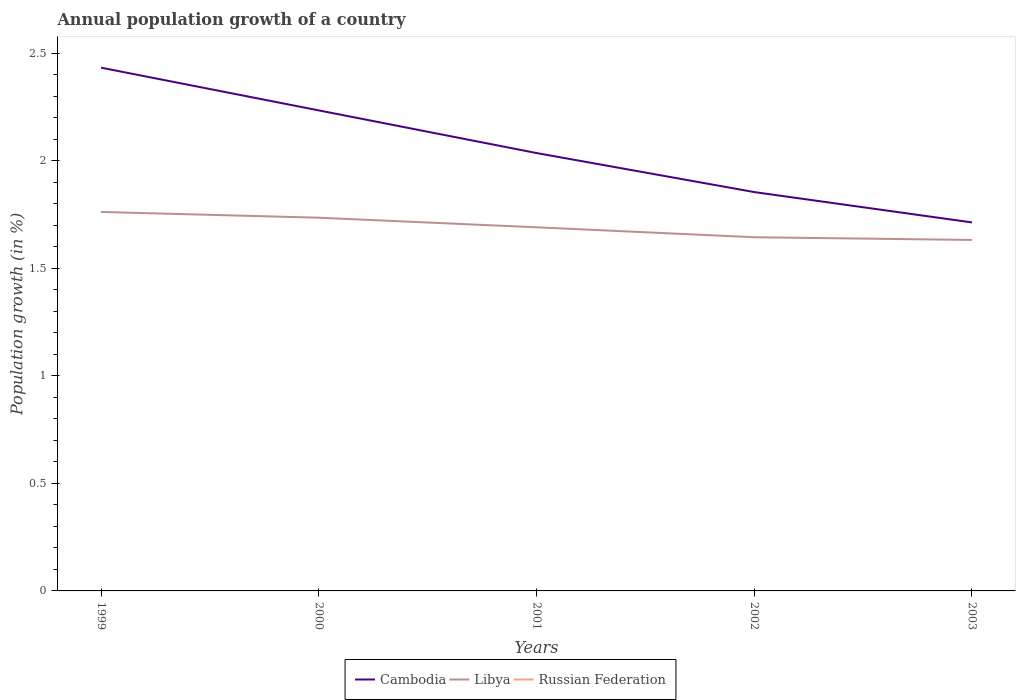Does the line corresponding to Libya intersect with the line corresponding to Cambodia?
Ensure brevity in your answer.  No. Across all years, what is the maximum annual population growth in Cambodia?
Make the answer very short. 1.71. What is the total annual population growth in Cambodia in the graph?
Ensure brevity in your answer.  0.2. What is the difference between the highest and the second highest annual population growth in Cambodia?
Your response must be concise. 0.72. What is the difference between the highest and the lowest annual population growth in Russian Federation?
Keep it short and to the point. 0. How many lines are there?
Offer a terse response. 2. How many years are there in the graph?
Give a very brief answer. 5. Does the graph contain any zero values?
Keep it short and to the point. Yes. Where does the legend appear in the graph?
Give a very brief answer. Bottom center. What is the title of the graph?
Keep it short and to the point. Annual population growth of a country. Does "San Marino" appear as one of the legend labels in the graph?
Make the answer very short. No. What is the label or title of the X-axis?
Your answer should be compact. Years. What is the label or title of the Y-axis?
Ensure brevity in your answer.  Population growth (in %). What is the Population growth (in %) in Cambodia in 1999?
Give a very brief answer. 2.43. What is the Population growth (in %) in Libya in 1999?
Offer a very short reply. 1.76. What is the Population growth (in %) in Russian Federation in 1999?
Offer a very short reply. 0. What is the Population growth (in %) of Cambodia in 2000?
Offer a very short reply. 2.23. What is the Population growth (in %) in Libya in 2000?
Your answer should be very brief. 1.74. What is the Population growth (in %) of Cambodia in 2001?
Your response must be concise. 2.04. What is the Population growth (in %) in Libya in 2001?
Provide a short and direct response. 1.69. What is the Population growth (in %) of Cambodia in 2002?
Provide a succinct answer. 1.86. What is the Population growth (in %) of Libya in 2002?
Provide a short and direct response. 1.65. What is the Population growth (in %) of Cambodia in 2003?
Keep it short and to the point. 1.71. What is the Population growth (in %) in Libya in 2003?
Your answer should be compact. 1.63. Across all years, what is the maximum Population growth (in %) of Cambodia?
Offer a very short reply. 2.43. Across all years, what is the maximum Population growth (in %) in Libya?
Your response must be concise. 1.76. Across all years, what is the minimum Population growth (in %) in Cambodia?
Your answer should be compact. 1.71. Across all years, what is the minimum Population growth (in %) of Libya?
Keep it short and to the point. 1.63. What is the total Population growth (in %) in Cambodia in the graph?
Ensure brevity in your answer.  10.27. What is the total Population growth (in %) in Libya in the graph?
Provide a short and direct response. 8.47. What is the difference between the Population growth (in %) of Cambodia in 1999 and that in 2000?
Make the answer very short. 0.2. What is the difference between the Population growth (in %) of Libya in 1999 and that in 2000?
Your answer should be very brief. 0.03. What is the difference between the Population growth (in %) in Cambodia in 1999 and that in 2001?
Your answer should be compact. 0.4. What is the difference between the Population growth (in %) in Libya in 1999 and that in 2001?
Offer a terse response. 0.07. What is the difference between the Population growth (in %) in Cambodia in 1999 and that in 2002?
Provide a short and direct response. 0.58. What is the difference between the Population growth (in %) of Libya in 1999 and that in 2002?
Give a very brief answer. 0.12. What is the difference between the Population growth (in %) in Cambodia in 1999 and that in 2003?
Your answer should be very brief. 0.72. What is the difference between the Population growth (in %) of Libya in 1999 and that in 2003?
Your answer should be compact. 0.13. What is the difference between the Population growth (in %) in Cambodia in 2000 and that in 2001?
Ensure brevity in your answer.  0.2. What is the difference between the Population growth (in %) in Libya in 2000 and that in 2001?
Offer a very short reply. 0.04. What is the difference between the Population growth (in %) in Cambodia in 2000 and that in 2002?
Provide a short and direct response. 0.38. What is the difference between the Population growth (in %) of Libya in 2000 and that in 2002?
Offer a very short reply. 0.09. What is the difference between the Population growth (in %) of Cambodia in 2000 and that in 2003?
Provide a short and direct response. 0.52. What is the difference between the Population growth (in %) in Libya in 2000 and that in 2003?
Provide a succinct answer. 0.1. What is the difference between the Population growth (in %) of Cambodia in 2001 and that in 2002?
Offer a very short reply. 0.18. What is the difference between the Population growth (in %) in Libya in 2001 and that in 2002?
Your answer should be compact. 0.05. What is the difference between the Population growth (in %) in Cambodia in 2001 and that in 2003?
Give a very brief answer. 0.32. What is the difference between the Population growth (in %) of Libya in 2001 and that in 2003?
Keep it short and to the point. 0.06. What is the difference between the Population growth (in %) in Cambodia in 2002 and that in 2003?
Offer a very short reply. 0.14. What is the difference between the Population growth (in %) of Libya in 2002 and that in 2003?
Your answer should be very brief. 0.01. What is the difference between the Population growth (in %) in Cambodia in 1999 and the Population growth (in %) in Libya in 2000?
Your answer should be compact. 0.7. What is the difference between the Population growth (in %) of Cambodia in 1999 and the Population growth (in %) of Libya in 2001?
Your answer should be compact. 0.74. What is the difference between the Population growth (in %) in Cambodia in 1999 and the Population growth (in %) in Libya in 2002?
Your answer should be compact. 0.79. What is the difference between the Population growth (in %) in Cambodia in 1999 and the Population growth (in %) in Libya in 2003?
Keep it short and to the point. 0.8. What is the difference between the Population growth (in %) of Cambodia in 2000 and the Population growth (in %) of Libya in 2001?
Your response must be concise. 0.54. What is the difference between the Population growth (in %) in Cambodia in 2000 and the Population growth (in %) in Libya in 2002?
Provide a short and direct response. 0.59. What is the difference between the Population growth (in %) in Cambodia in 2000 and the Population growth (in %) in Libya in 2003?
Give a very brief answer. 0.6. What is the difference between the Population growth (in %) of Cambodia in 2001 and the Population growth (in %) of Libya in 2002?
Offer a terse response. 0.39. What is the difference between the Population growth (in %) of Cambodia in 2001 and the Population growth (in %) of Libya in 2003?
Your answer should be compact. 0.4. What is the difference between the Population growth (in %) of Cambodia in 2002 and the Population growth (in %) of Libya in 2003?
Keep it short and to the point. 0.22. What is the average Population growth (in %) of Cambodia per year?
Offer a terse response. 2.05. What is the average Population growth (in %) of Libya per year?
Provide a short and direct response. 1.69. What is the average Population growth (in %) of Russian Federation per year?
Make the answer very short. 0. In the year 1999, what is the difference between the Population growth (in %) of Cambodia and Population growth (in %) of Libya?
Your answer should be very brief. 0.67. In the year 2000, what is the difference between the Population growth (in %) in Cambodia and Population growth (in %) in Libya?
Keep it short and to the point. 0.5. In the year 2001, what is the difference between the Population growth (in %) in Cambodia and Population growth (in %) in Libya?
Offer a terse response. 0.35. In the year 2002, what is the difference between the Population growth (in %) of Cambodia and Population growth (in %) of Libya?
Ensure brevity in your answer.  0.21. In the year 2003, what is the difference between the Population growth (in %) in Cambodia and Population growth (in %) in Libya?
Give a very brief answer. 0.08. What is the ratio of the Population growth (in %) of Cambodia in 1999 to that in 2000?
Give a very brief answer. 1.09. What is the ratio of the Population growth (in %) of Libya in 1999 to that in 2000?
Your answer should be very brief. 1.02. What is the ratio of the Population growth (in %) of Cambodia in 1999 to that in 2001?
Offer a terse response. 1.2. What is the ratio of the Population growth (in %) in Libya in 1999 to that in 2001?
Offer a terse response. 1.04. What is the ratio of the Population growth (in %) of Cambodia in 1999 to that in 2002?
Provide a short and direct response. 1.31. What is the ratio of the Population growth (in %) of Libya in 1999 to that in 2002?
Your answer should be very brief. 1.07. What is the ratio of the Population growth (in %) of Cambodia in 1999 to that in 2003?
Provide a short and direct response. 1.42. What is the ratio of the Population growth (in %) of Libya in 1999 to that in 2003?
Your answer should be very brief. 1.08. What is the ratio of the Population growth (in %) in Cambodia in 2000 to that in 2001?
Your answer should be compact. 1.1. What is the ratio of the Population growth (in %) in Libya in 2000 to that in 2001?
Keep it short and to the point. 1.03. What is the ratio of the Population growth (in %) in Cambodia in 2000 to that in 2002?
Your answer should be compact. 1.2. What is the ratio of the Population growth (in %) in Libya in 2000 to that in 2002?
Offer a very short reply. 1.06. What is the ratio of the Population growth (in %) in Cambodia in 2000 to that in 2003?
Offer a very short reply. 1.3. What is the ratio of the Population growth (in %) in Libya in 2000 to that in 2003?
Provide a short and direct response. 1.06. What is the ratio of the Population growth (in %) of Cambodia in 2001 to that in 2002?
Provide a succinct answer. 1.1. What is the ratio of the Population growth (in %) in Libya in 2001 to that in 2002?
Your answer should be compact. 1.03. What is the ratio of the Population growth (in %) of Cambodia in 2001 to that in 2003?
Offer a terse response. 1.19. What is the ratio of the Population growth (in %) of Libya in 2001 to that in 2003?
Your answer should be very brief. 1.04. What is the ratio of the Population growth (in %) of Cambodia in 2002 to that in 2003?
Offer a terse response. 1.08. What is the ratio of the Population growth (in %) of Libya in 2002 to that in 2003?
Offer a very short reply. 1.01. What is the difference between the highest and the second highest Population growth (in %) in Cambodia?
Ensure brevity in your answer.  0.2. What is the difference between the highest and the second highest Population growth (in %) in Libya?
Ensure brevity in your answer.  0.03. What is the difference between the highest and the lowest Population growth (in %) of Cambodia?
Your response must be concise. 0.72. What is the difference between the highest and the lowest Population growth (in %) in Libya?
Ensure brevity in your answer.  0.13. 